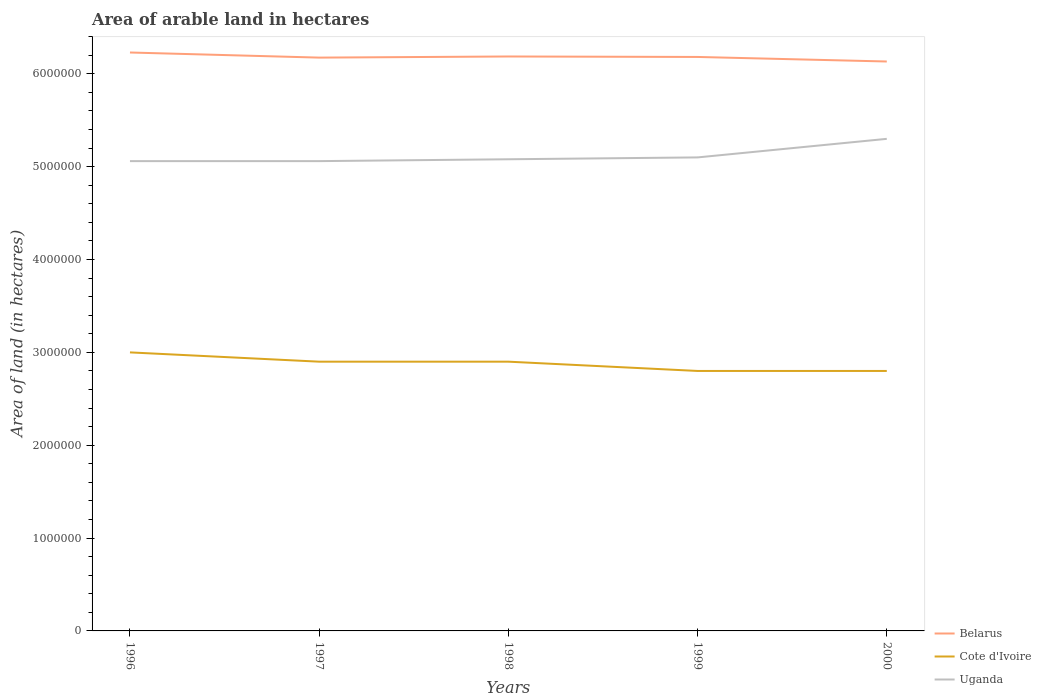Does the line corresponding to Cote d'Ivoire intersect with the line corresponding to Uganda?
Your answer should be very brief. No. Is the number of lines equal to the number of legend labels?
Ensure brevity in your answer.  Yes. Across all years, what is the maximum total arable land in Belarus?
Provide a succinct answer. 6.13e+06. In which year was the total arable land in Uganda maximum?
Offer a terse response. 1996. What is the total total arable land in Uganda in the graph?
Keep it short and to the point. -2.40e+05. What is the difference between the highest and the second highest total arable land in Cote d'Ivoire?
Keep it short and to the point. 2.00e+05. How many lines are there?
Keep it short and to the point. 3. What is the difference between two consecutive major ticks on the Y-axis?
Keep it short and to the point. 1.00e+06. What is the title of the graph?
Provide a succinct answer. Area of arable land in hectares. Does "Lao PDR" appear as one of the legend labels in the graph?
Offer a terse response. No. What is the label or title of the Y-axis?
Offer a very short reply. Area of land (in hectares). What is the Area of land (in hectares) in Belarus in 1996?
Offer a very short reply. 6.23e+06. What is the Area of land (in hectares) of Uganda in 1996?
Provide a succinct answer. 5.06e+06. What is the Area of land (in hectares) of Belarus in 1997?
Your response must be concise. 6.18e+06. What is the Area of land (in hectares) in Cote d'Ivoire in 1997?
Your response must be concise. 2.90e+06. What is the Area of land (in hectares) of Uganda in 1997?
Your answer should be very brief. 5.06e+06. What is the Area of land (in hectares) in Belarus in 1998?
Ensure brevity in your answer.  6.19e+06. What is the Area of land (in hectares) in Cote d'Ivoire in 1998?
Ensure brevity in your answer.  2.90e+06. What is the Area of land (in hectares) in Uganda in 1998?
Offer a very short reply. 5.08e+06. What is the Area of land (in hectares) of Belarus in 1999?
Your answer should be compact. 6.18e+06. What is the Area of land (in hectares) in Cote d'Ivoire in 1999?
Keep it short and to the point. 2.80e+06. What is the Area of land (in hectares) in Uganda in 1999?
Ensure brevity in your answer.  5.10e+06. What is the Area of land (in hectares) in Belarus in 2000?
Provide a short and direct response. 6.13e+06. What is the Area of land (in hectares) of Cote d'Ivoire in 2000?
Offer a terse response. 2.80e+06. What is the Area of land (in hectares) in Uganda in 2000?
Your answer should be compact. 5.30e+06. Across all years, what is the maximum Area of land (in hectares) of Belarus?
Make the answer very short. 6.23e+06. Across all years, what is the maximum Area of land (in hectares) of Cote d'Ivoire?
Offer a terse response. 3.00e+06. Across all years, what is the maximum Area of land (in hectares) of Uganda?
Offer a very short reply. 5.30e+06. Across all years, what is the minimum Area of land (in hectares) in Belarus?
Your answer should be very brief. 6.13e+06. Across all years, what is the minimum Area of land (in hectares) of Cote d'Ivoire?
Provide a short and direct response. 2.80e+06. Across all years, what is the minimum Area of land (in hectares) of Uganda?
Ensure brevity in your answer.  5.06e+06. What is the total Area of land (in hectares) of Belarus in the graph?
Offer a terse response. 3.09e+07. What is the total Area of land (in hectares) in Cote d'Ivoire in the graph?
Your response must be concise. 1.44e+07. What is the total Area of land (in hectares) of Uganda in the graph?
Offer a terse response. 2.56e+07. What is the difference between the Area of land (in hectares) in Belarus in 1996 and that in 1997?
Your response must be concise. 5.50e+04. What is the difference between the Area of land (in hectares) of Belarus in 1996 and that in 1998?
Provide a short and direct response. 4.30e+04. What is the difference between the Area of land (in hectares) of Cote d'Ivoire in 1996 and that in 1998?
Your answer should be compact. 1.00e+05. What is the difference between the Area of land (in hectares) in Belarus in 1996 and that in 1999?
Your response must be concise. 4.80e+04. What is the difference between the Area of land (in hectares) of Cote d'Ivoire in 1996 and that in 1999?
Offer a very short reply. 2.00e+05. What is the difference between the Area of land (in hectares) in Belarus in 1996 and that in 2000?
Provide a succinct answer. 9.70e+04. What is the difference between the Area of land (in hectares) of Belarus in 1997 and that in 1998?
Make the answer very short. -1.20e+04. What is the difference between the Area of land (in hectares) in Cote d'Ivoire in 1997 and that in 1998?
Give a very brief answer. 0. What is the difference between the Area of land (in hectares) of Uganda in 1997 and that in 1998?
Provide a short and direct response. -2.00e+04. What is the difference between the Area of land (in hectares) of Belarus in 1997 and that in 1999?
Give a very brief answer. -7000. What is the difference between the Area of land (in hectares) of Uganda in 1997 and that in 1999?
Ensure brevity in your answer.  -4.00e+04. What is the difference between the Area of land (in hectares) in Belarus in 1997 and that in 2000?
Provide a short and direct response. 4.20e+04. What is the difference between the Area of land (in hectares) of Cote d'Ivoire in 1997 and that in 2000?
Keep it short and to the point. 1.00e+05. What is the difference between the Area of land (in hectares) of Cote d'Ivoire in 1998 and that in 1999?
Your answer should be very brief. 1.00e+05. What is the difference between the Area of land (in hectares) in Belarus in 1998 and that in 2000?
Offer a very short reply. 5.40e+04. What is the difference between the Area of land (in hectares) in Belarus in 1999 and that in 2000?
Your answer should be very brief. 4.90e+04. What is the difference between the Area of land (in hectares) in Cote d'Ivoire in 1999 and that in 2000?
Provide a succinct answer. 0. What is the difference between the Area of land (in hectares) of Uganda in 1999 and that in 2000?
Your answer should be very brief. -2.00e+05. What is the difference between the Area of land (in hectares) of Belarus in 1996 and the Area of land (in hectares) of Cote d'Ivoire in 1997?
Your answer should be compact. 3.33e+06. What is the difference between the Area of land (in hectares) of Belarus in 1996 and the Area of land (in hectares) of Uganda in 1997?
Offer a terse response. 1.17e+06. What is the difference between the Area of land (in hectares) of Cote d'Ivoire in 1996 and the Area of land (in hectares) of Uganda in 1997?
Your response must be concise. -2.06e+06. What is the difference between the Area of land (in hectares) in Belarus in 1996 and the Area of land (in hectares) in Cote d'Ivoire in 1998?
Make the answer very short. 3.33e+06. What is the difference between the Area of land (in hectares) of Belarus in 1996 and the Area of land (in hectares) of Uganda in 1998?
Ensure brevity in your answer.  1.15e+06. What is the difference between the Area of land (in hectares) of Cote d'Ivoire in 1996 and the Area of land (in hectares) of Uganda in 1998?
Ensure brevity in your answer.  -2.08e+06. What is the difference between the Area of land (in hectares) in Belarus in 1996 and the Area of land (in hectares) in Cote d'Ivoire in 1999?
Keep it short and to the point. 3.43e+06. What is the difference between the Area of land (in hectares) in Belarus in 1996 and the Area of land (in hectares) in Uganda in 1999?
Offer a terse response. 1.13e+06. What is the difference between the Area of land (in hectares) of Cote d'Ivoire in 1996 and the Area of land (in hectares) of Uganda in 1999?
Ensure brevity in your answer.  -2.10e+06. What is the difference between the Area of land (in hectares) of Belarus in 1996 and the Area of land (in hectares) of Cote d'Ivoire in 2000?
Offer a very short reply. 3.43e+06. What is the difference between the Area of land (in hectares) in Belarus in 1996 and the Area of land (in hectares) in Uganda in 2000?
Your answer should be compact. 9.30e+05. What is the difference between the Area of land (in hectares) in Cote d'Ivoire in 1996 and the Area of land (in hectares) in Uganda in 2000?
Provide a short and direct response. -2.30e+06. What is the difference between the Area of land (in hectares) of Belarus in 1997 and the Area of land (in hectares) of Cote d'Ivoire in 1998?
Ensure brevity in your answer.  3.28e+06. What is the difference between the Area of land (in hectares) in Belarus in 1997 and the Area of land (in hectares) in Uganda in 1998?
Ensure brevity in your answer.  1.10e+06. What is the difference between the Area of land (in hectares) of Cote d'Ivoire in 1997 and the Area of land (in hectares) of Uganda in 1998?
Your answer should be compact. -2.18e+06. What is the difference between the Area of land (in hectares) in Belarus in 1997 and the Area of land (in hectares) in Cote d'Ivoire in 1999?
Give a very brief answer. 3.38e+06. What is the difference between the Area of land (in hectares) in Belarus in 1997 and the Area of land (in hectares) in Uganda in 1999?
Offer a terse response. 1.08e+06. What is the difference between the Area of land (in hectares) in Cote d'Ivoire in 1997 and the Area of land (in hectares) in Uganda in 1999?
Ensure brevity in your answer.  -2.20e+06. What is the difference between the Area of land (in hectares) in Belarus in 1997 and the Area of land (in hectares) in Cote d'Ivoire in 2000?
Keep it short and to the point. 3.38e+06. What is the difference between the Area of land (in hectares) in Belarus in 1997 and the Area of land (in hectares) in Uganda in 2000?
Keep it short and to the point. 8.75e+05. What is the difference between the Area of land (in hectares) in Cote d'Ivoire in 1997 and the Area of land (in hectares) in Uganda in 2000?
Keep it short and to the point. -2.40e+06. What is the difference between the Area of land (in hectares) in Belarus in 1998 and the Area of land (in hectares) in Cote d'Ivoire in 1999?
Keep it short and to the point. 3.39e+06. What is the difference between the Area of land (in hectares) of Belarus in 1998 and the Area of land (in hectares) of Uganda in 1999?
Offer a very short reply. 1.09e+06. What is the difference between the Area of land (in hectares) in Cote d'Ivoire in 1998 and the Area of land (in hectares) in Uganda in 1999?
Provide a short and direct response. -2.20e+06. What is the difference between the Area of land (in hectares) in Belarus in 1998 and the Area of land (in hectares) in Cote d'Ivoire in 2000?
Provide a short and direct response. 3.39e+06. What is the difference between the Area of land (in hectares) in Belarus in 1998 and the Area of land (in hectares) in Uganda in 2000?
Your response must be concise. 8.87e+05. What is the difference between the Area of land (in hectares) of Cote d'Ivoire in 1998 and the Area of land (in hectares) of Uganda in 2000?
Ensure brevity in your answer.  -2.40e+06. What is the difference between the Area of land (in hectares) in Belarus in 1999 and the Area of land (in hectares) in Cote d'Ivoire in 2000?
Give a very brief answer. 3.38e+06. What is the difference between the Area of land (in hectares) of Belarus in 1999 and the Area of land (in hectares) of Uganda in 2000?
Make the answer very short. 8.82e+05. What is the difference between the Area of land (in hectares) of Cote d'Ivoire in 1999 and the Area of land (in hectares) of Uganda in 2000?
Ensure brevity in your answer.  -2.50e+06. What is the average Area of land (in hectares) of Belarus per year?
Give a very brief answer. 6.18e+06. What is the average Area of land (in hectares) in Cote d'Ivoire per year?
Give a very brief answer. 2.88e+06. What is the average Area of land (in hectares) in Uganda per year?
Offer a very short reply. 5.12e+06. In the year 1996, what is the difference between the Area of land (in hectares) of Belarus and Area of land (in hectares) of Cote d'Ivoire?
Provide a short and direct response. 3.23e+06. In the year 1996, what is the difference between the Area of land (in hectares) of Belarus and Area of land (in hectares) of Uganda?
Offer a very short reply. 1.17e+06. In the year 1996, what is the difference between the Area of land (in hectares) in Cote d'Ivoire and Area of land (in hectares) in Uganda?
Make the answer very short. -2.06e+06. In the year 1997, what is the difference between the Area of land (in hectares) of Belarus and Area of land (in hectares) of Cote d'Ivoire?
Give a very brief answer. 3.28e+06. In the year 1997, what is the difference between the Area of land (in hectares) in Belarus and Area of land (in hectares) in Uganda?
Ensure brevity in your answer.  1.12e+06. In the year 1997, what is the difference between the Area of land (in hectares) in Cote d'Ivoire and Area of land (in hectares) in Uganda?
Your response must be concise. -2.16e+06. In the year 1998, what is the difference between the Area of land (in hectares) of Belarus and Area of land (in hectares) of Cote d'Ivoire?
Give a very brief answer. 3.29e+06. In the year 1998, what is the difference between the Area of land (in hectares) of Belarus and Area of land (in hectares) of Uganda?
Your answer should be compact. 1.11e+06. In the year 1998, what is the difference between the Area of land (in hectares) in Cote d'Ivoire and Area of land (in hectares) in Uganda?
Ensure brevity in your answer.  -2.18e+06. In the year 1999, what is the difference between the Area of land (in hectares) in Belarus and Area of land (in hectares) in Cote d'Ivoire?
Offer a very short reply. 3.38e+06. In the year 1999, what is the difference between the Area of land (in hectares) in Belarus and Area of land (in hectares) in Uganda?
Your response must be concise. 1.08e+06. In the year 1999, what is the difference between the Area of land (in hectares) in Cote d'Ivoire and Area of land (in hectares) in Uganda?
Make the answer very short. -2.30e+06. In the year 2000, what is the difference between the Area of land (in hectares) in Belarus and Area of land (in hectares) in Cote d'Ivoire?
Ensure brevity in your answer.  3.33e+06. In the year 2000, what is the difference between the Area of land (in hectares) of Belarus and Area of land (in hectares) of Uganda?
Provide a succinct answer. 8.33e+05. In the year 2000, what is the difference between the Area of land (in hectares) in Cote d'Ivoire and Area of land (in hectares) in Uganda?
Offer a terse response. -2.50e+06. What is the ratio of the Area of land (in hectares) of Belarus in 1996 to that in 1997?
Provide a short and direct response. 1.01. What is the ratio of the Area of land (in hectares) in Cote d'Ivoire in 1996 to that in 1997?
Provide a succinct answer. 1.03. What is the ratio of the Area of land (in hectares) of Uganda in 1996 to that in 1997?
Provide a short and direct response. 1. What is the ratio of the Area of land (in hectares) in Belarus in 1996 to that in 1998?
Ensure brevity in your answer.  1.01. What is the ratio of the Area of land (in hectares) of Cote d'Ivoire in 1996 to that in 1998?
Offer a terse response. 1.03. What is the ratio of the Area of land (in hectares) of Uganda in 1996 to that in 1998?
Offer a terse response. 1. What is the ratio of the Area of land (in hectares) of Cote d'Ivoire in 1996 to that in 1999?
Offer a very short reply. 1.07. What is the ratio of the Area of land (in hectares) in Uganda in 1996 to that in 1999?
Make the answer very short. 0.99. What is the ratio of the Area of land (in hectares) in Belarus in 1996 to that in 2000?
Make the answer very short. 1.02. What is the ratio of the Area of land (in hectares) of Cote d'Ivoire in 1996 to that in 2000?
Offer a very short reply. 1.07. What is the ratio of the Area of land (in hectares) in Uganda in 1996 to that in 2000?
Provide a succinct answer. 0.95. What is the ratio of the Area of land (in hectares) in Belarus in 1997 to that in 1999?
Keep it short and to the point. 1. What is the ratio of the Area of land (in hectares) in Cote d'Ivoire in 1997 to that in 1999?
Your answer should be very brief. 1.04. What is the ratio of the Area of land (in hectares) in Uganda in 1997 to that in 1999?
Ensure brevity in your answer.  0.99. What is the ratio of the Area of land (in hectares) of Belarus in 1997 to that in 2000?
Make the answer very short. 1.01. What is the ratio of the Area of land (in hectares) of Cote d'Ivoire in 1997 to that in 2000?
Give a very brief answer. 1.04. What is the ratio of the Area of land (in hectares) of Uganda in 1997 to that in 2000?
Your answer should be compact. 0.95. What is the ratio of the Area of land (in hectares) in Cote d'Ivoire in 1998 to that in 1999?
Make the answer very short. 1.04. What is the ratio of the Area of land (in hectares) of Belarus in 1998 to that in 2000?
Provide a succinct answer. 1.01. What is the ratio of the Area of land (in hectares) of Cote d'Ivoire in 1998 to that in 2000?
Ensure brevity in your answer.  1.04. What is the ratio of the Area of land (in hectares) in Uganda in 1998 to that in 2000?
Provide a short and direct response. 0.96. What is the ratio of the Area of land (in hectares) of Cote d'Ivoire in 1999 to that in 2000?
Keep it short and to the point. 1. What is the ratio of the Area of land (in hectares) of Uganda in 1999 to that in 2000?
Offer a terse response. 0.96. What is the difference between the highest and the second highest Area of land (in hectares) of Belarus?
Your response must be concise. 4.30e+04. What is the difference between the highest and the lowest Area of land (in hectares) of Belarus?
Ensure brevity in your answer.  9.70e+04. What is the difference between the highest and the lowest Area of land (in hectares) in Cote d'Ivoire?
Offer a terse response. 2.00e+05. 